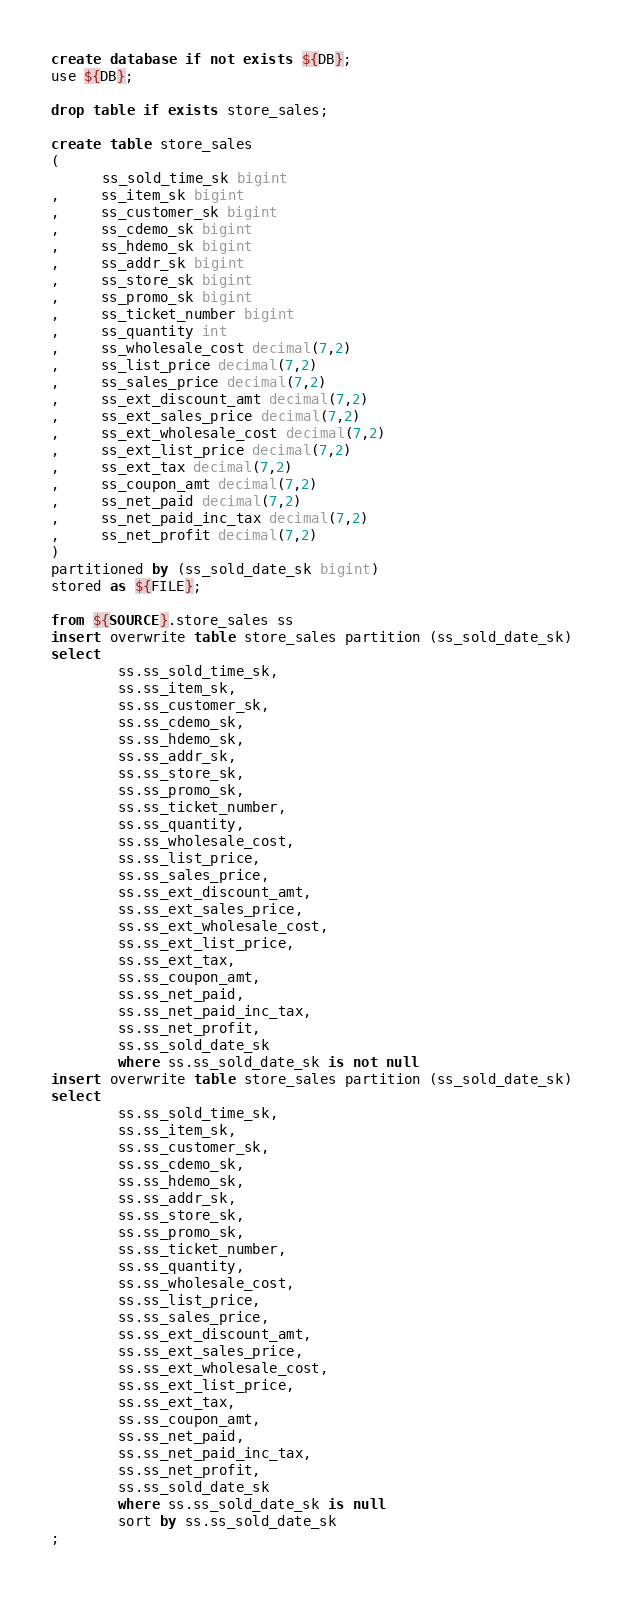Convert code to text. <code><loc_0><loc_0><loc_500><loc_500><_SQL_>create database if not exists ${DB};
use ${DB};

drop table if exists store_sales;

create table store_sales
(
      ss_sold_time_sk bigint
,     ss_item_sk bigint
,     ss_customer_sk bigint
,     ss_cdemo_sk bigint
,     ss_hdemo_sk bigint
,     ss_addr_sk bigint
,     ss_store_sk bigint
,     ss_promo_sk bigint
,     ss_ticket_number bigint
,     ss_quantity int
,     ss_wholesale_cost decimal(7,2)
,     ss_list_price decimal(7,2)
,     ss_sales_price decimal(7,2)
,     ss_ext_discount_amt decimal(7,2)
,     ss_ext_sales_price decimal(7,2)
,     ss_ext_wholesale_cost decimal(7,2)
,     ss_ext_list_price decimal(7,2)
,     ss_ext_tax decimal(7,2)
,     ss_coupon_amt decimal(7,2)
,     ss_net_paid decimal(7,2)
,     ss_net_paid_inc_tax decimal(7,2)
,     ss_net_profit decimal(7,2)
)
partitioned by (ss_sold_date_sk bigint)
stored as ${FILE};

from ${SOURCE}.store_sales ss
insert overwrite table store_sales partition (ss_sold_date_sk) 
select
        ss.ss_sold_time_sk,
        ss.ss_item_sk,
        ss.ss_customer_sk,
        ss.ss_cdemo_sk,
        ss.ss_hdemo_sk,
        ss.ss_addr_sk,
        ss.ss_store_sk,
        ss.ss_promo_sk,
        ss.ss_ticket_number,
        ss.ss_quantity,
        ss.ss_wholesale_cost,
        ss.ss_list_price,
        ss.ss_sales_price,
        ss.ss_ext_discount_amt,
        ss.ss_ext_sales_price,
        ss.ss_ext_wholesale_cost,
        ss.ss_ext_list_price,
        ss.ss_ext_tax,
        ss.ss_coupon_amt,
        ss.ss_net_paid,
        ss.ss_net_paid_inc_tax,
        ss.ss_net_profit,
        ss.ss_sold_date_sk
        where ss.ss_sold_date_sk is not null
insert overwrite table store_sales partition (ss_sold_date_sk) 
select
        ss.ss_sold_time_sk,
        ss.ss_item_sk,
        ss.ss_customer_sk,
        ss.ss_cdemo_sk,
        ss.ss_hdemo_sk,
        ss.ss_addr_sk,
        ss.ss_store_sk,
        ss.ss_promo_sk,
        ss.ss_ticket_number,
        ss.ss_quantity,
        ss.ss_wholesale_cost,
        ss.ss_list_price,
        ss.ss_sales_price,
        ss.ss_ext_discount_amt,
        ss.ss_ext_sales_price,
        ss.ss_ext_wholesale_cost,
        ss.ss_ext_list_price,
        ss.ss_ext_tax,
        ss.ss_coupon_amt,
        ss.ss_net_paid,
        ss.ss_net_paid_inc_tax,
        ss.ss_net_profit,
        ss.ss_sold_date_sk
        where ss.ss_sold_date_sk is null
        sort by ss.ss_sold_date_sk
;
</code> 